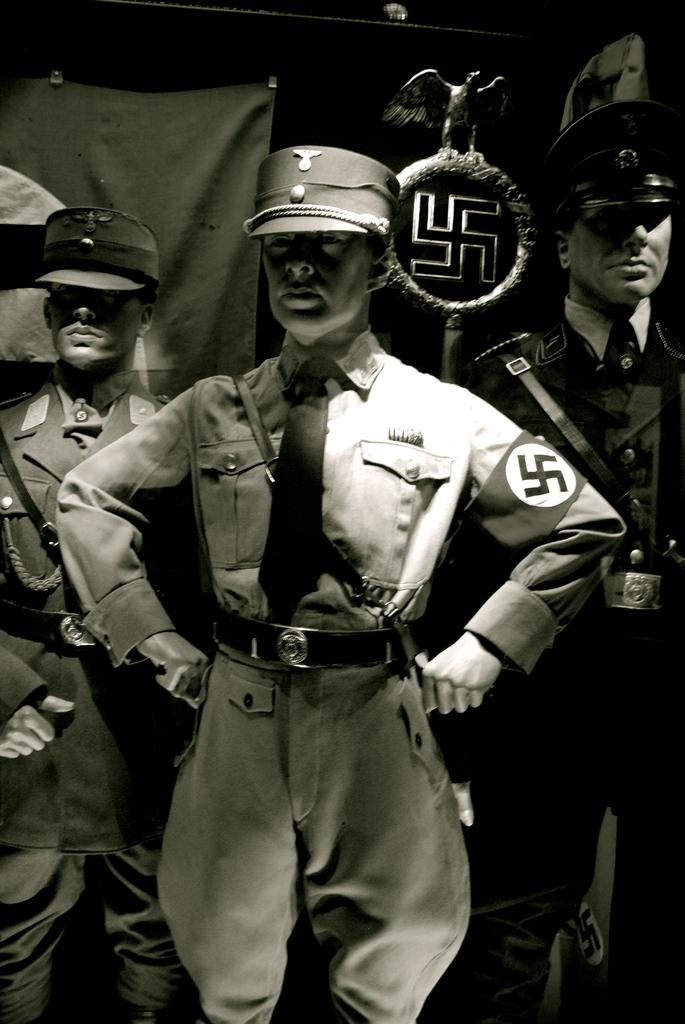How many people are in the image? There are three people in the image. What are the people wearing? The people are wearing uniforms. What can be seen in the background of the image? There is a logo in the background of the image. What is depicted on the logo? The logo features a statue of a bird. What type of leather is used to make the bird's wings in the image? There is no bird with leather wings present in the image; the logo features a statue of a bird. 